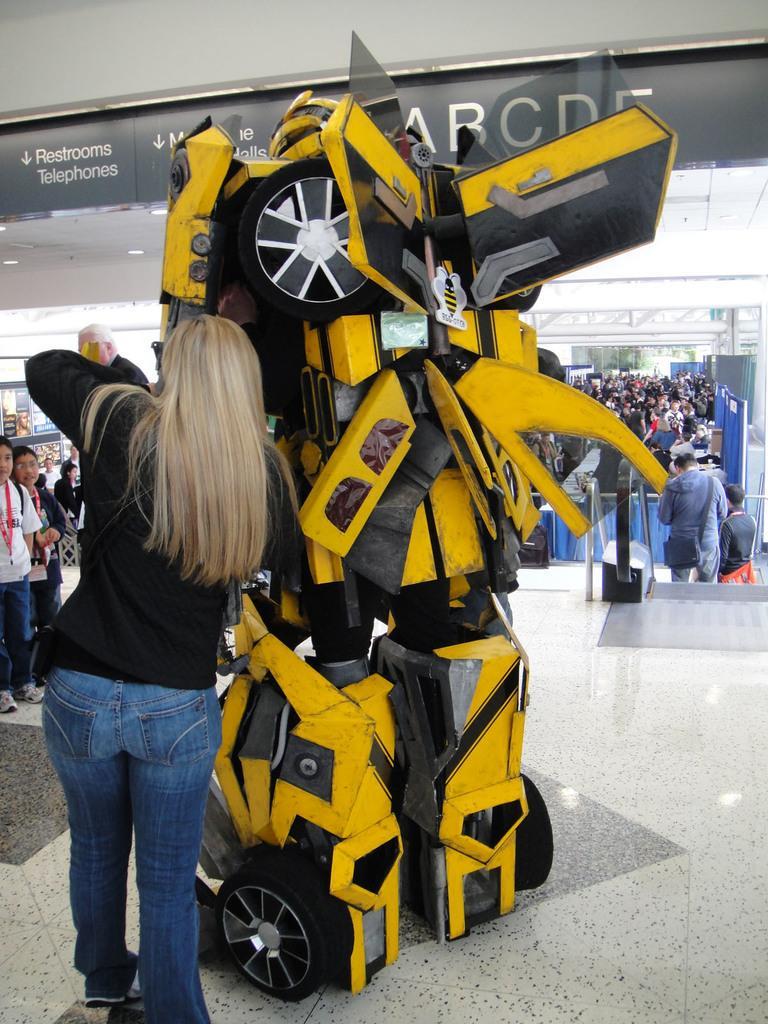In one or two sentences, can you explain what this image depicts? In this image, in the foreground we can see a person standing, and a robotic car and at the back there are many people standing. 